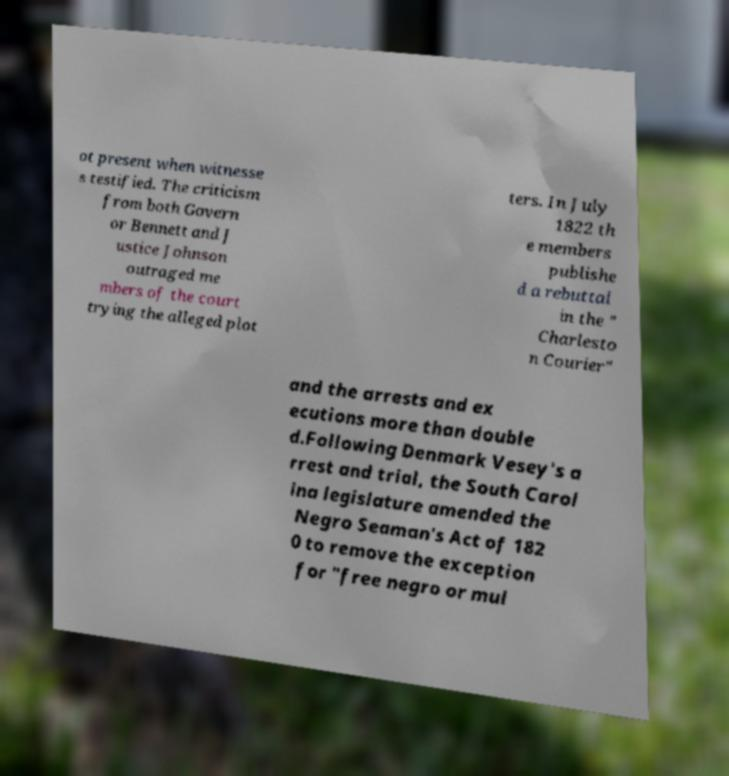Please identify and transcribe the text found in this image. ot present when witnesse s testified. The criticism from both Govern or Bennett and J ustice Johnson outraged me mbers of the court trying the alleged plot ters. In July 1822 th e members publishe d a rebuttal in the " Charlesto n Courier" and the arrests and ex ecutions more than double d.Following Denmark Vesey's a rrest and trial, the South Carol ina legislature amended the Negro Seaman's Act of 182 0 to remove the exception for "free negro or mul 